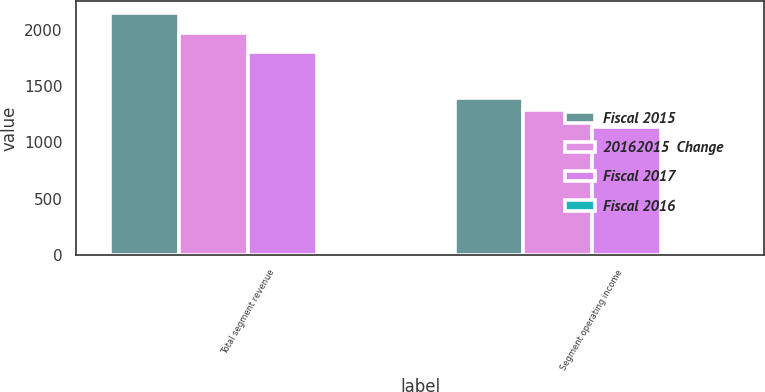Convert chart to OTSL. <chart><loc_0><loc_0><loc_500><loc_500><stacked_bar_chart><ecel><fcel>Total segment revenue<fcel>Segment operating income<nl><fcel>Fiscal 2015<fcel>2143<fcel>1392<nl><fcel>20162015  Change<fcel>1973<fcel>1289<nl><fcel>Fiscal 2017<fcel>1800<fcel>1134<nl><fcel>Fiscal 2016<fcel>9<fcel>8<nl></chart> 